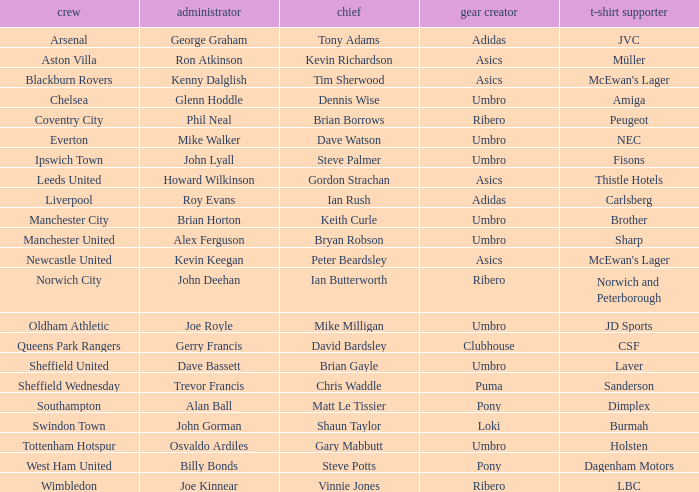Which captain has billy bonds as the manager? Steve Potts. 